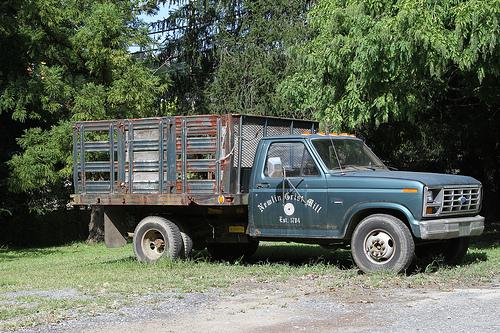Question: what color are the wheels?
Choices:
A. Gray.
B. Black.
C. Silver.
D. Charcoal.
Answer with the letter. Answer: B Question: how many vehicles are parked?
Choices:
A. 2.
B. 8.
C. 1.
D. 9.
Answer with the letter. Answer: C 